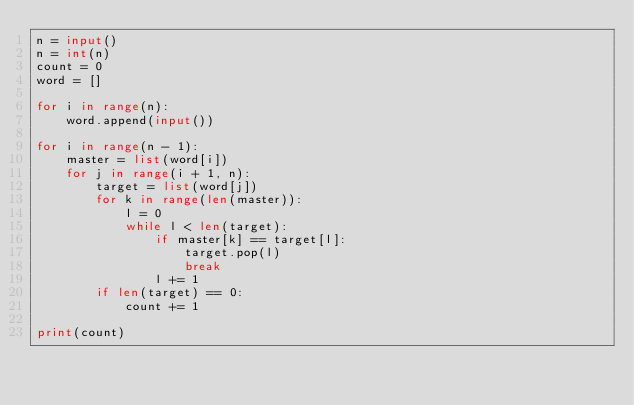Convert code to text. <code><loc_0><loc_0><loc_500><loc_500><_Python_>n = input()
n = int(n)
count = 0
word = []

for i in range(n):
    word.append(input())

for i in range(n - 1):    
    master = list(word[i])
    for j in range(i + 1, n):
        target = list(word[j])
        for k in range(len(master)):
            l = 0
            while l < len(target):
                if master[k] == target[l]:
                    target.pop(l)
                    break
                l += 1
        if len(target) == 0:
            count += 1

print(count)</code> 